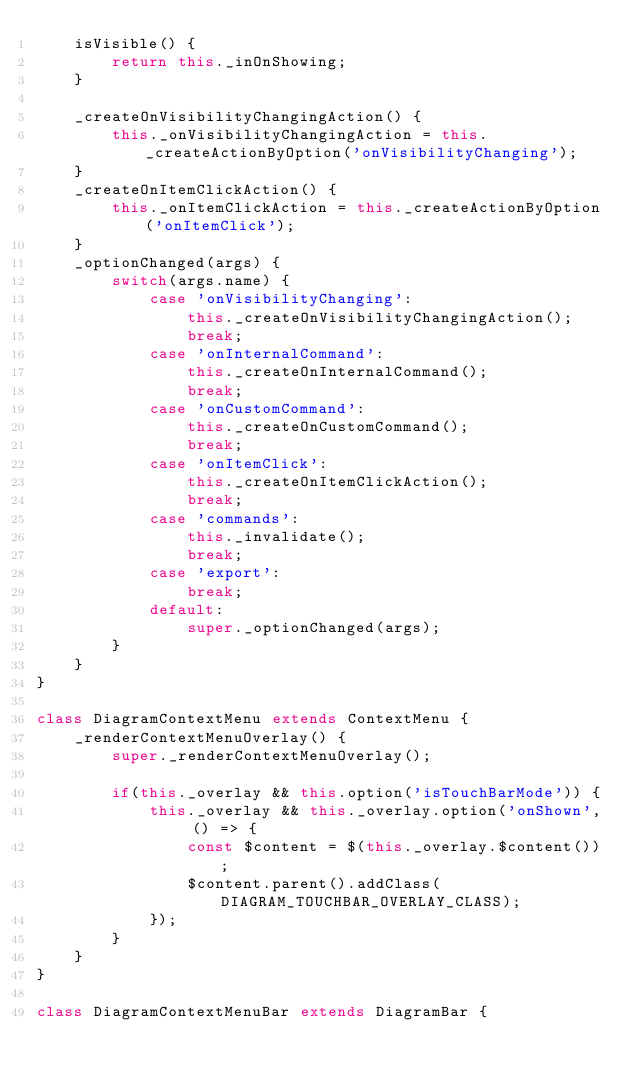Convert code to text. <code><loc_0><loc_0><loc_500><loc_500><_JavaScript_>    isVisible() {
        return this._inOnShowing;
    }

    _createOnVisibilityChangingAction() {
        this._onVisibilityChangingAction = this._createActionByOption('onVisibilityChanging');
    }
    _createOnItemClickAction() {
        this._onItemClickAction = this._createActionByOption('onItemClick');
    }
    _optionChanged(args) {
        switch(args.name) {
            case 'onVisibilityChanging':
                this._createOnVisibilityChangingAction();
                break;
            case 'onInternalCommand':
                this._createOnInternalCommand();
                break;
            case 'onCustomCommand':
                this._createOnCustomCommand();
                break;
            case 'onItemClick':
                this._createOnItemClickAction();
                break;
            case 'commands':
                this._invalidate();
                break;
            case 'export':
                break;
            default:
                super._optionChanged(args);
        }
    }
}

class DiagramContextMenu extends ContextMenu {
    _renderContextMenuOverlay() {
        super._renderContextMenuOverlay();

        if(this._overlay && this.option('isTouchBarMode')) {
            this._overlay && this._overlay.option('onShown', () => {
                const $content = $(this._overlay.$content());
                $content.parent().addClass(DIAGRAM_TOUCHBAR_OVERLAY_CLASS);
            });
        }
    }
}

class DiagramContextMenuBar extends DiagramBar {</code> 